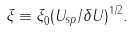Convert formula to latex. <formula><loc_0><loc_0><loc_500><loc_500>\xi _ { \| } \equiv \xi _ { 0 } ^ { \| } ( U _ { s p } / \delta U ) ^ { 1 / 2 } .</formula> 